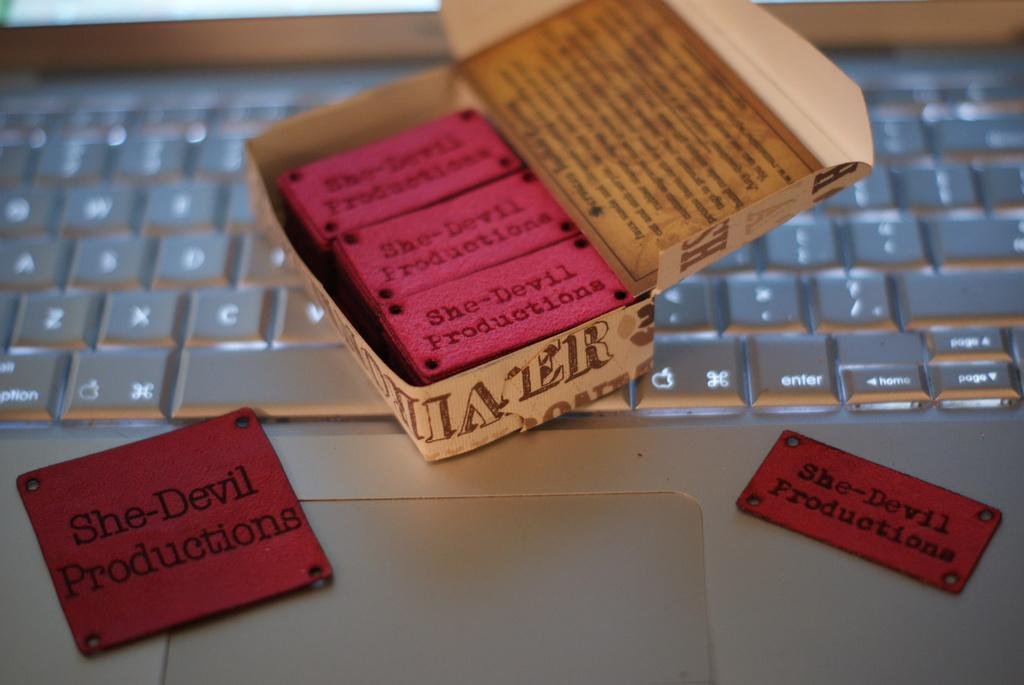Provide a one-sentence caption for the provided image. A case of stickers that say She-Devil Productions rests on top of a keyboard. 